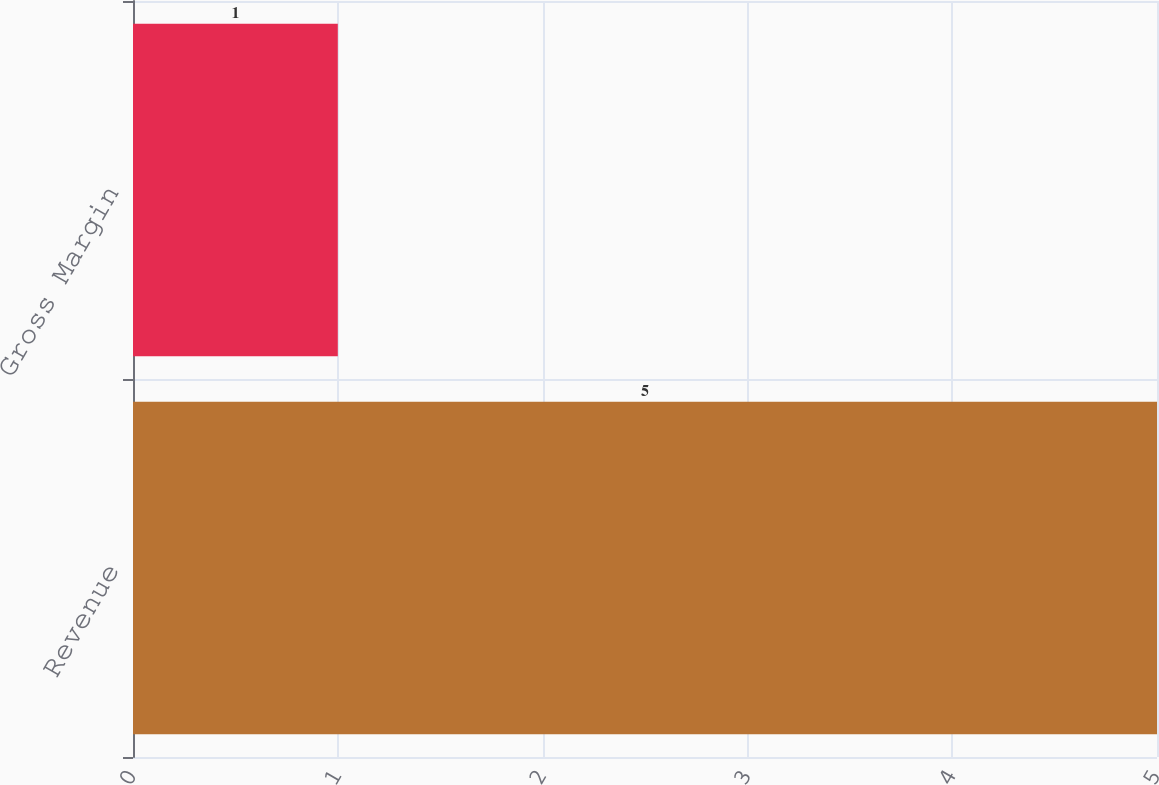<chart> <loc_0><loc_0><loc_500><loc_500><bar_chart><fcel>Revenue<fcel>Gross Margin<nl><fcel>5<fcel>1<nl></chart> 